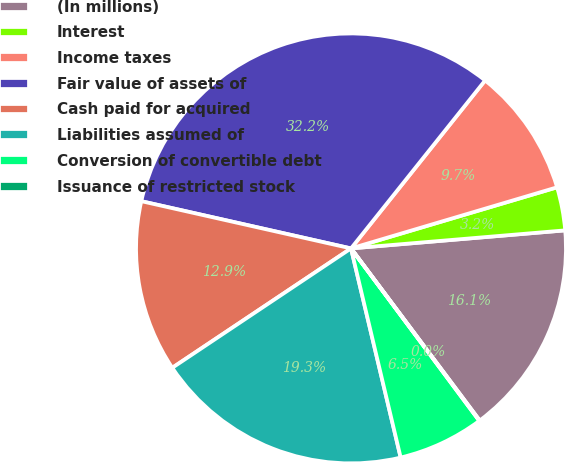<chart> <loc_0><loc_0><loc_500><loc_500><pie_chart><fcel>(In millions)<fcel>Interest<fcel>Income taxes<fcel>Fair value of assets of<fcel>Cash paid for acquired<fcel>Liabilities assumed of<fcel>Conversion of convertible debt<fcel>Issuance of restricted stock<nl><fcel>16.12%<fcel>3.25%<fcel>9.69%<fcel>32.2%<fcel>12.9%<fcel>19.34%<fcel>6.47%<fcel>0.04%<nl></chart> 